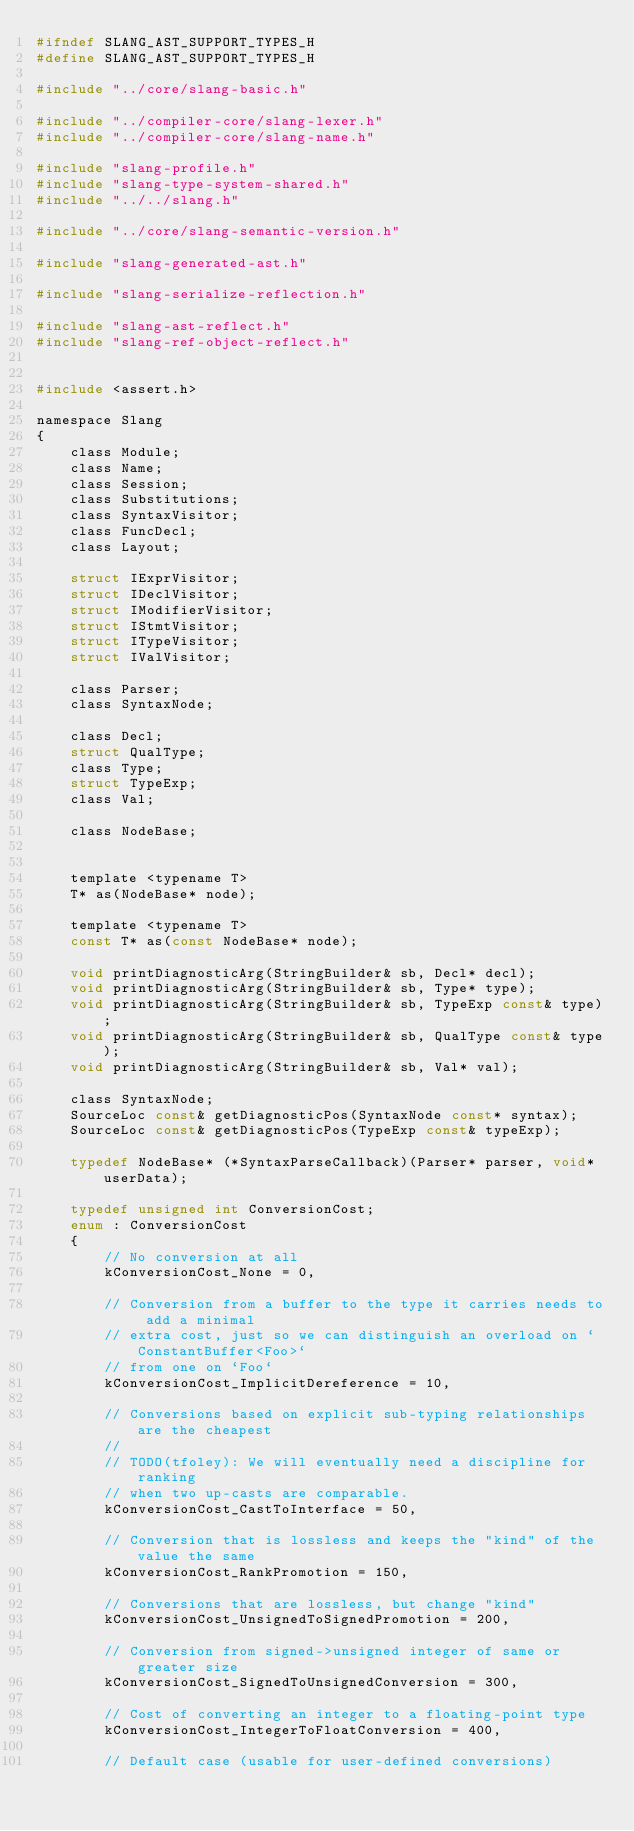<code> <loc_0><loc_0><loc_500><loc_500><_C_>#ifndef SLANG_AST_SUPPORT_TYPES_H
#define SLANG_AST_SUPPORT_TYPES_H

#include "../core/slang-basic.h"

#include "../compiler-core/slang-lexer.h"
#include "../compiler-core/slang-name.h"

#include "slang-profile.h"
#include "slang-type-system-shared.h"
#include "../../slang.h"

#include "../core/slang-semantic-version.h"

#include "slang-generated-ast.h" 

#include "slang-serialize-reflection.h"

#include "slang-ast-reflect.h"
#include "slang-ref-object-reflect.h"


#include <assert.h>

namespace Slang
{
    class Module;
    class Name;
    class Session;
    class Substitutions;
    class SyntaxVisitor;
    class FuncDecl;
    class Layout;

    struct IExprVisitor;
    struct IDeclVisitor;
    struct IModifierVisitor;
    struct IStmtVisitor;
    struct ITypeVisitor;
    struct IValVisitor;

    class Parser;
    class SyntaxNode;

    class Decl;
    struct QualType;
    class Type;
    struct TypeExp;
    class Val;

    class NodeBase;


    template <typename T>
    T* as(NodeBase* node);

    template <typename T>
    const T* as(const NodeBase* node);

    void printDiagnosticArg(StringBuilder& sb, Decl* decl);
    void printDiagnosticArg(StringBuilder& sb, Type* type);
    void printDiagnosticArg(StringBuilder& sb, TypeExp const& type);
    void printDiagnosticArg(StringBuilder& sb, QualType const& type);
    void printDiagnosticArg(StringBuilder& sb, Val* val);

    class SyntaxNode;
    SourceLoc const& getDiagnosticPos(SyntaxNode const* syntax);
    SourceLoc const& getDiagnosticPos(TypeExp const& typeExp);

    typedef NodeBase* (*SyntaxParseCallback)(Parser* parser, void* userData);

    typedef unsigned int ConversionCost;
    enum : ConversionCost
    {
        // No conversion at all
        kConversionCost_None = 0,

        // Conversion from a buffer to the type it carries needs to add a minimal
        // extra cost, just so we can distinguish an overload on `ConstantBuffer<Foo>`
        // from one on `Foo`
        kConversionCost_ImplicitDereference = 10,

        // Conversions based on explicit sub-typing relationships are the cheapest
        //
        // TODO(tfoley): We will eventually need a discipline for ranking
        // when two up-casts are comparable.
        kConversionCost_CastToInterface = 50,

        // Conversion that is lossless and keeps the "kind" of the value the same
        kConversionCost_RankPromotion = 150,

        // Conversions that are lossless, but change "kind"
        kConversionCost_UnsignedToSignedPromotion = 200,

        // Conversion from signed->unsigned integer of same or greater size
        kConversionCost_SignedToUnsignedConversion = 300,

        // Cost of converting an integer to a floating-point type
        kConversionCost_IntegerToFloatConversion = 400,

        // Default case (usable for user-defined conversions)</code> 